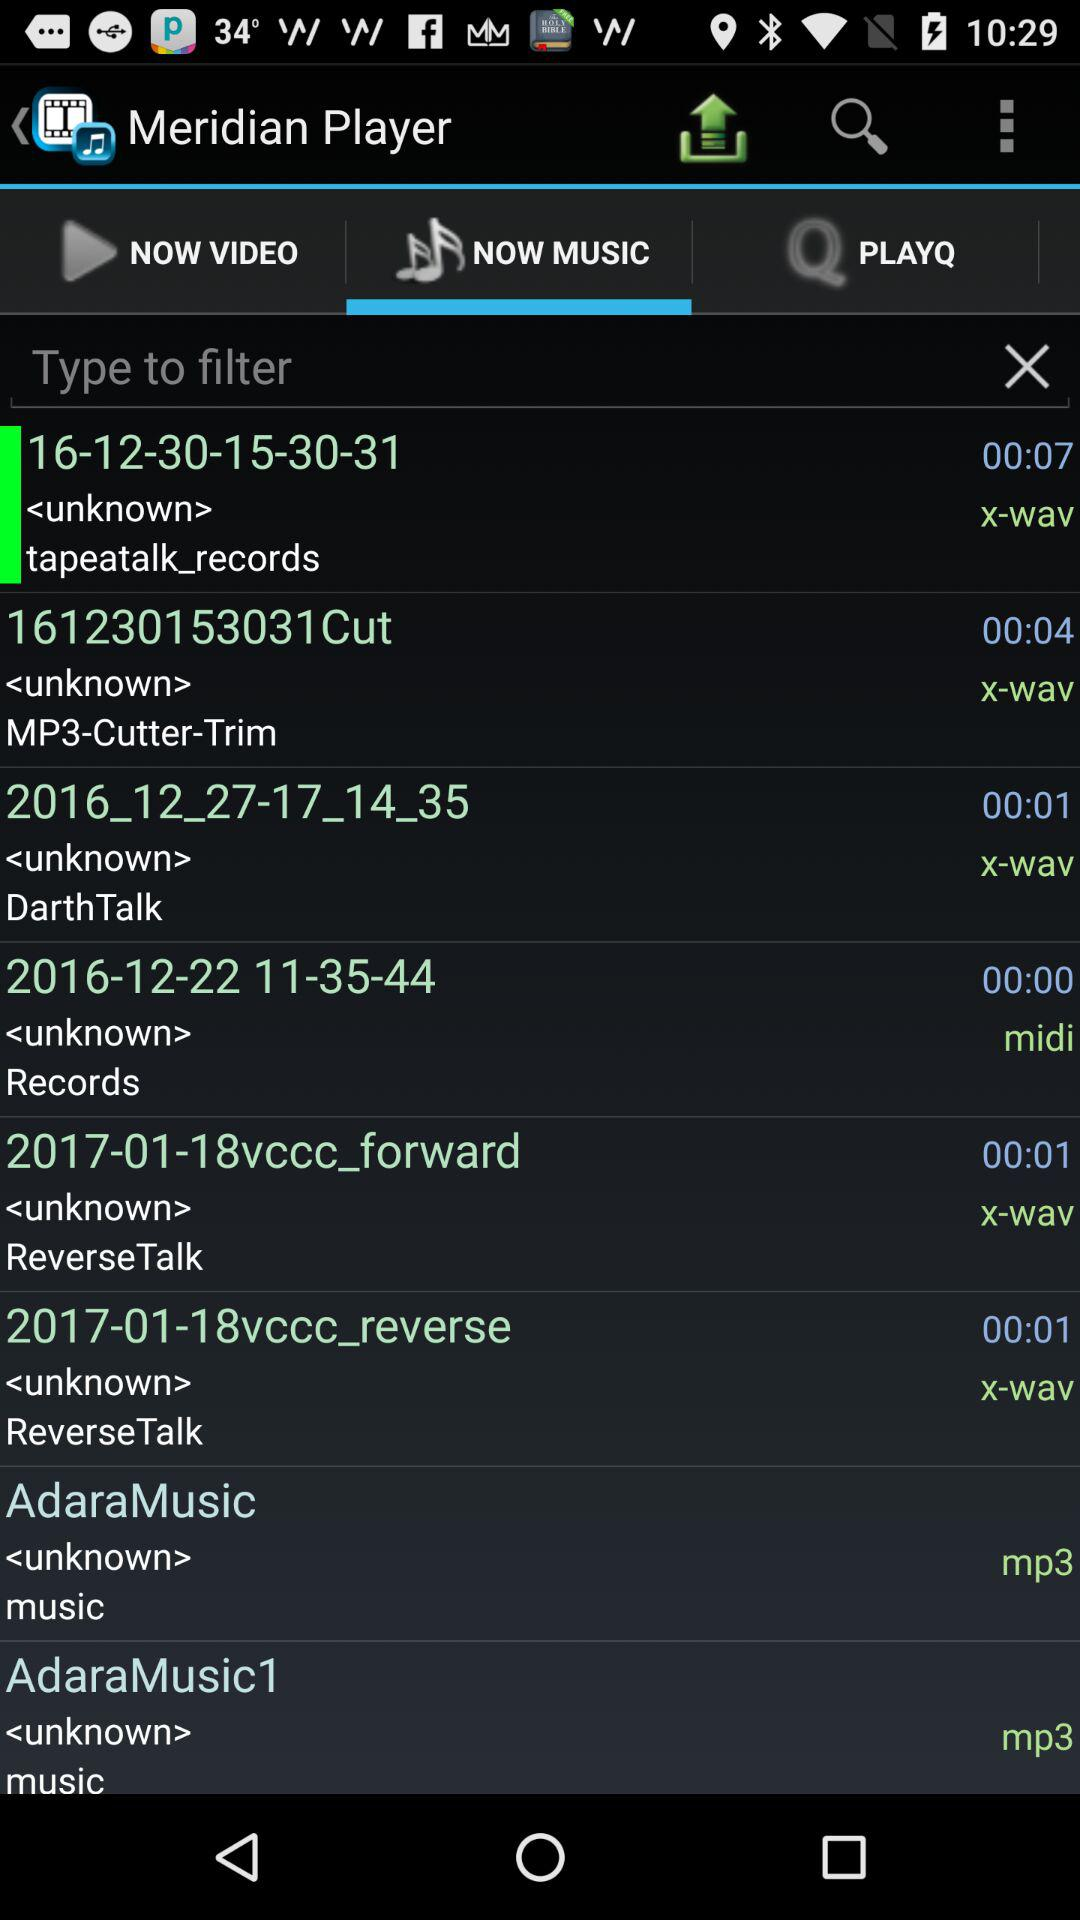Which type of file is "AdaraMusic"? "AdaraMusic" is an MP3 file. 